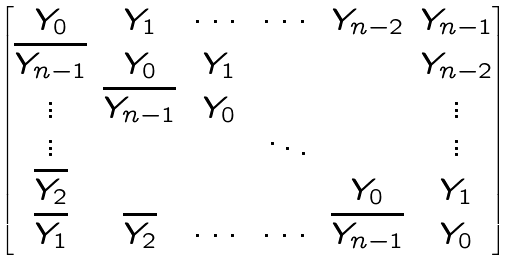<formula> <loc_0><loc_0><loc_500><loc_500>\begin{bmatrix} Y _ { 0 } & Y _ { 1 } & \cdots & \cdots & Y _ { n - 2 } & Y _ { n - 1 } \\ \overline { Y _ { n - 1 } } & Y _ { 0 } & Y _ { 1 } & & & Y _ { n - 2 } \\ \vdots & \overline { Y _ { n - 1 } } & Y _ { 0 } & & & \vdots \\ \vdots & & & \ddots & & \vdots \\ \overline { Y _ { 2 } } & & & & Y _ { 0 } & Y _ { 1 } \\ \overline { Y _ { 1 } } & \overline { Y _ { 2 } } & \cdots & \cdots & \overline { Y _ { n - 1 } } & Y _ { 0 } \end{bmatrix}</formula> 